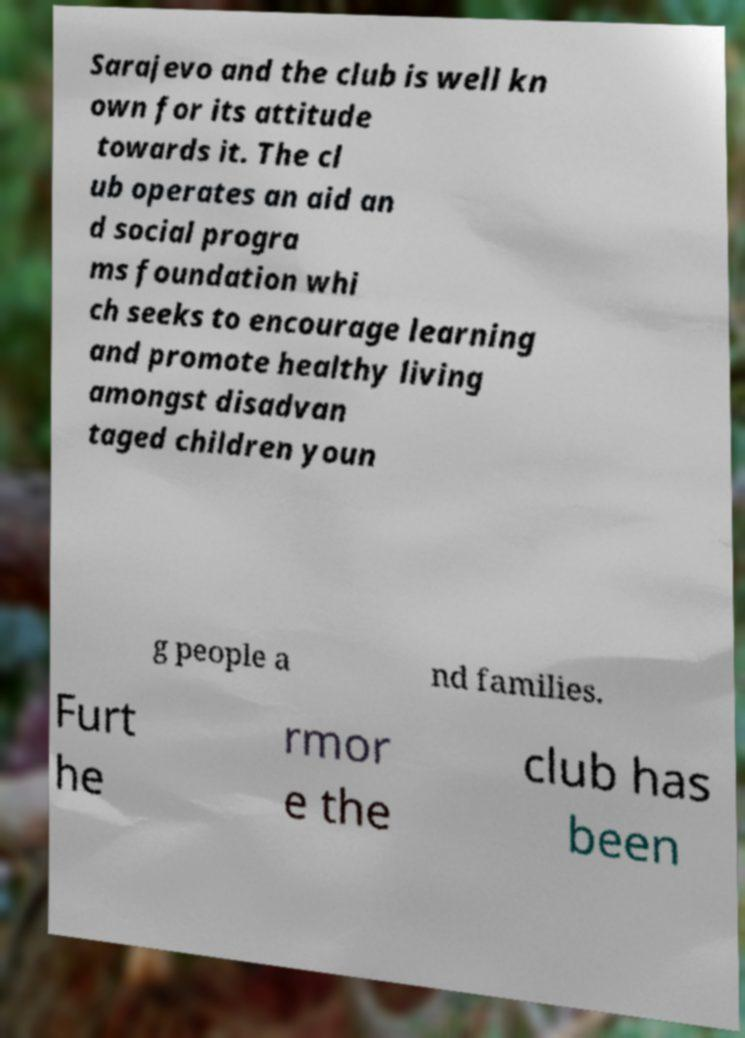I need the written content from this picture converted into text. Can you do that? Sarajevo and the club is well kn own for its attitude towards it. The cl ub operates an aid an d social progra ms foundation whi ch seeks to encourage learning and promote healthy living amongst disadvan taged children youn g people a nd families. Furt he rmor e the club has been 